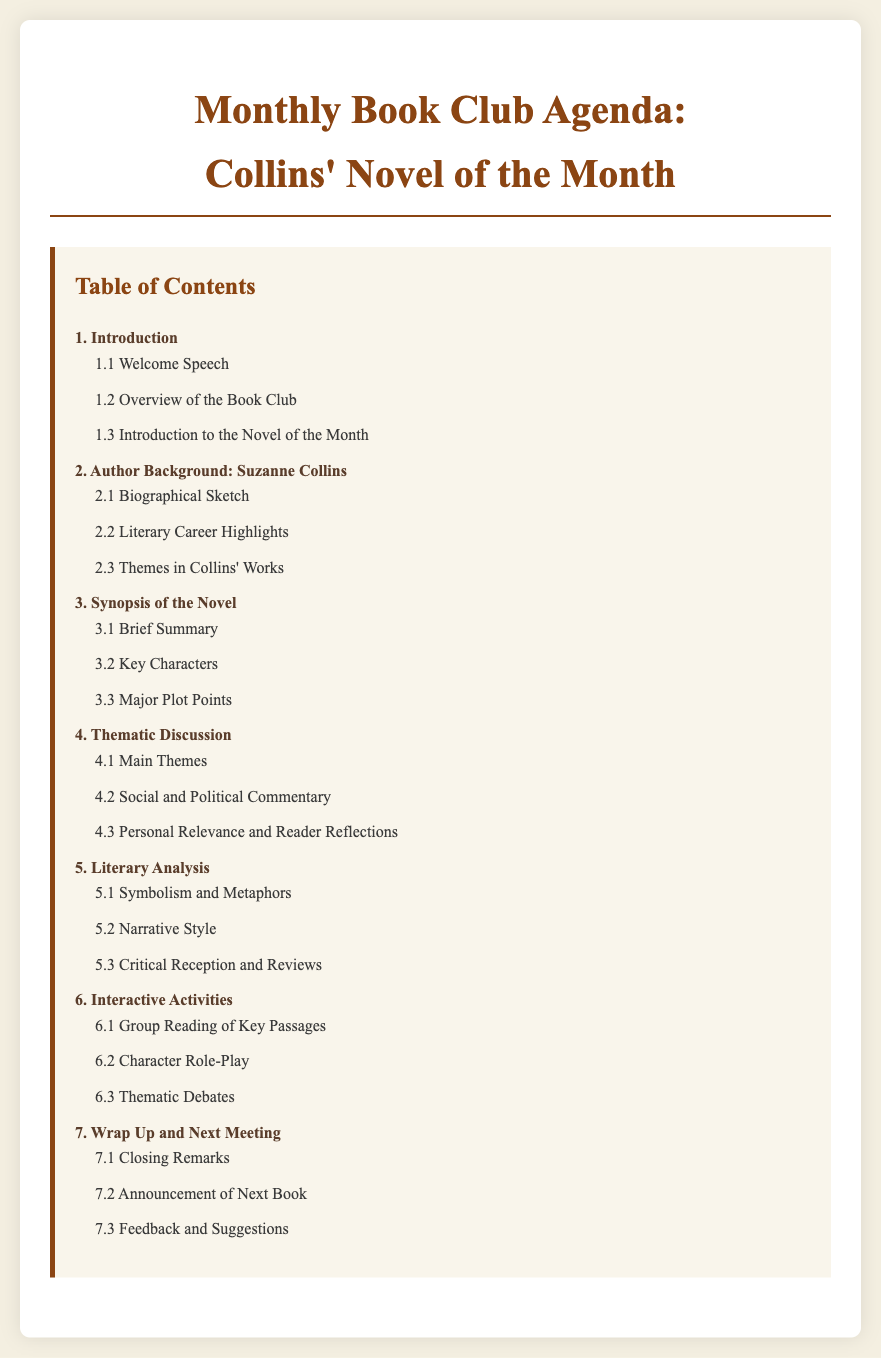What is the title of the document? The title, as seen in the header of the document, is "Monthly Book Club Agenda: Collins' Novel of the Month."
Answer: Monthly Book Club Agenda: Collins' Novel of the Month How many main sections are included in the Table of Contents? The Table of Contents lists a total of 7 main sections.
Answer: 7 What is the first subsection under "Introduction"? The first subsection listed under the "Introduction" section is "Welcome Speech."
Answer: Welcome Speech What is the focus of section 4? Section 4 is titled "Thematic Discussion" which focuses on various thematic aspects of the novel.
Answer: Thematic Discussion Which author is discussed in section 2? Section 2 discusses the background of the author Suzanne Collins.
Answer: Suzanne Collins What types of interactive activities are included in section 6? Section 6 includes activities such as "Group Reading of Key Passages," "Character Role-Play," and "Thematic Debates."
Answer: Group Reading of Key Passages, Character Role-Play, Thematic Debates What does section 7 conclude with? Section 7 wraps up with "Closing Remarks," "Announcement of Next Book," and "Feedback and Suggestions."
Answer: Closing Remarks, Announcement of Next Book, Feedback and Suggestions 